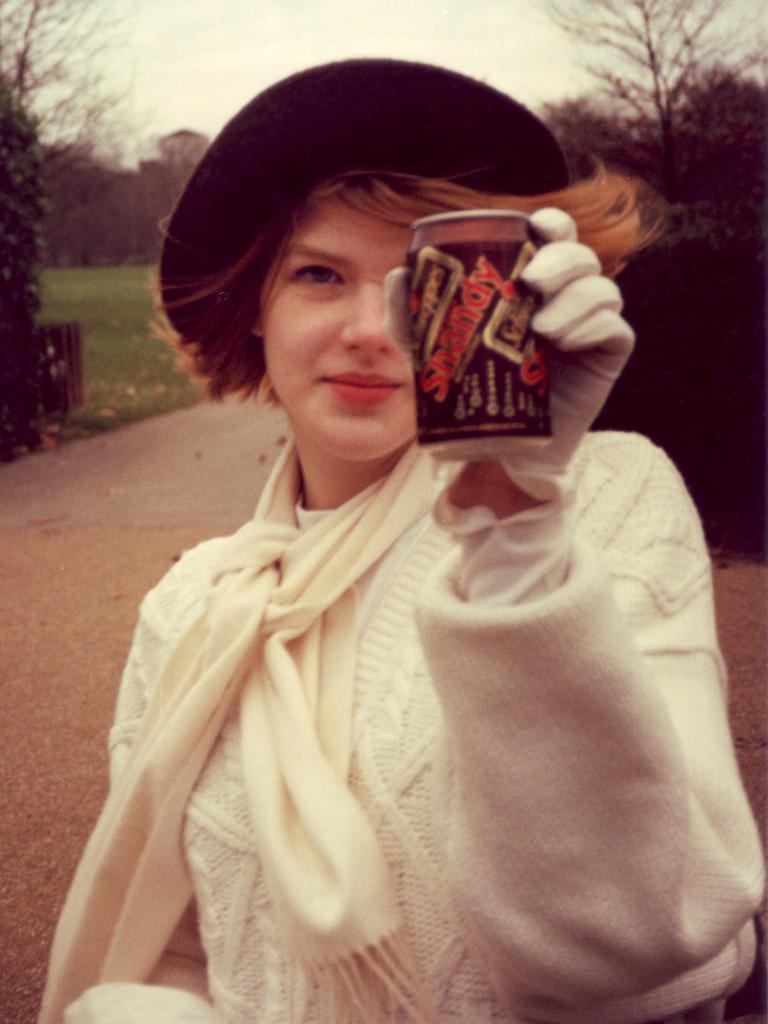Describe this image in one or two sentences. A woman is wearing a hat and also holding a tin her hand. 